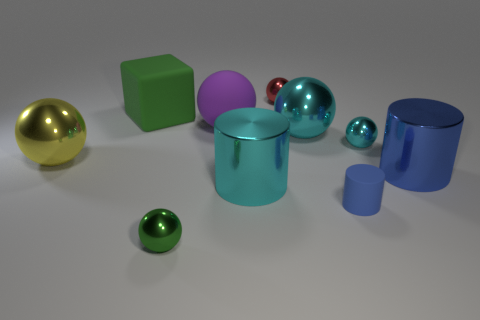Is the green ball made of the same material as the tiny blue cylinder?
Your answer should be compact. No. What number of cylinders are the same material as the big purple thing?
Provide a short and direct response. 1. What color is the big block that is the same material as the large purple sphere?
Your response must be concise. Green. There is a blue matte object; what shape is it?
Ensure brevity in your answer.  Cylinder. There is a big sphere to the left of the green ball; what material is it?
Make the answer very short. Metal. Are there any metal objects that have the same color as the tiny matte object?
Give a very brief answer. Yes. There is a yellow metal thing that is the same size as the green block; what shape is it?
Make the answer very short. Sphere. What is the color of the metal object in front of the small matte cylinder?
Keep it short and to the point. Green. Is there a cyan metallic thing that is left of the large rubber thing that is on the right side of the tiny green object?
Give a very brief answer. No. How many objects are either spheres to the right of the large green matte block or purple rubber things?
Give a very brief answer. 5. 